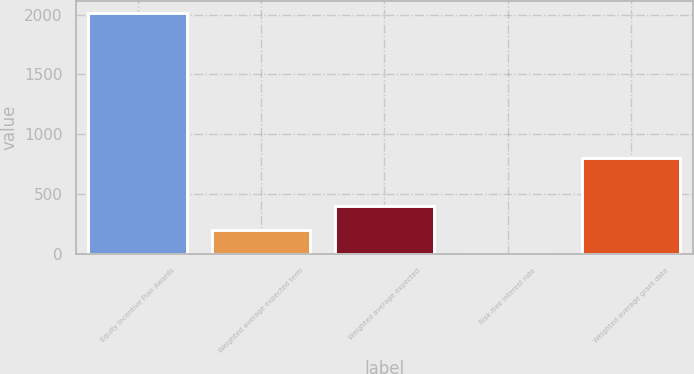Convert chart to OTSL. <chart><loc_0><loc_0><loc_500><loc_500><bar_chart><fcel>Equity Incentive Plan Awards<fcel>Weighted average expected term<fcel>Weighted average expected<fcel>Risk-free interest rate<fcel>Weighted average grant date<nl><fcel>2015<fcel>202.84<fcel>404.19<fcel>1.49<fcel>806.89<nl></chart> 